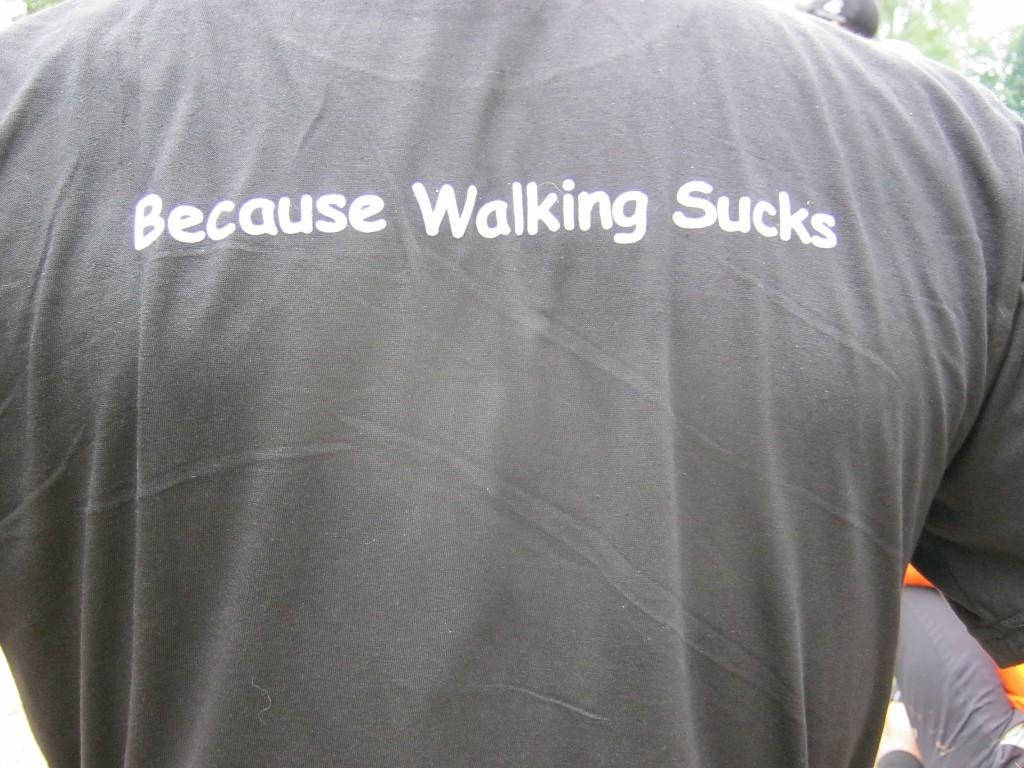What is present in the image? There is a person in the image. Can you describe what the person is wearing? The person is wearing a T-shirt. What is written on the T-shirt? The phrase "because walking sucks" is written on the T-shirt. What type of needle is the person using to sew on the image? There is no needle present in the image. What type of education does the person have in the image? There is no information about the person's education in the image. What type of nut is the person holding in the image? There is no nut present in the image. 